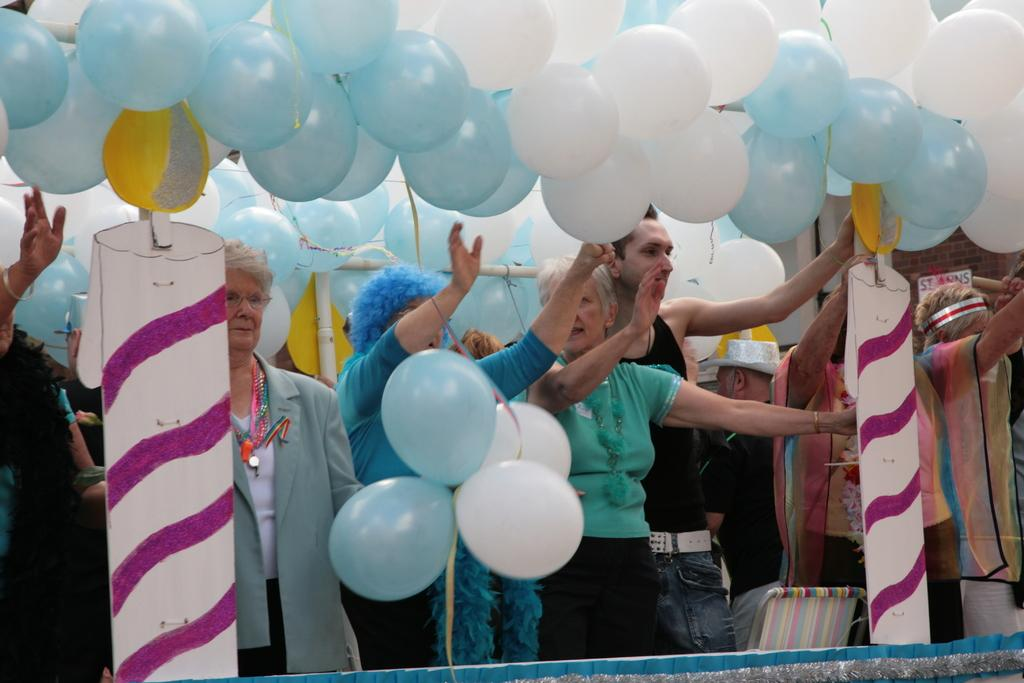What can be seen in the image involving people? There are people standing in the image. What else is present in the image besides people? There are balloons and a chair in the image. Where is the stove located in the image? There is no stove present in the image. What type of stocking is being worn by the people in the image? The image does not show any stockings being worn by the people. 